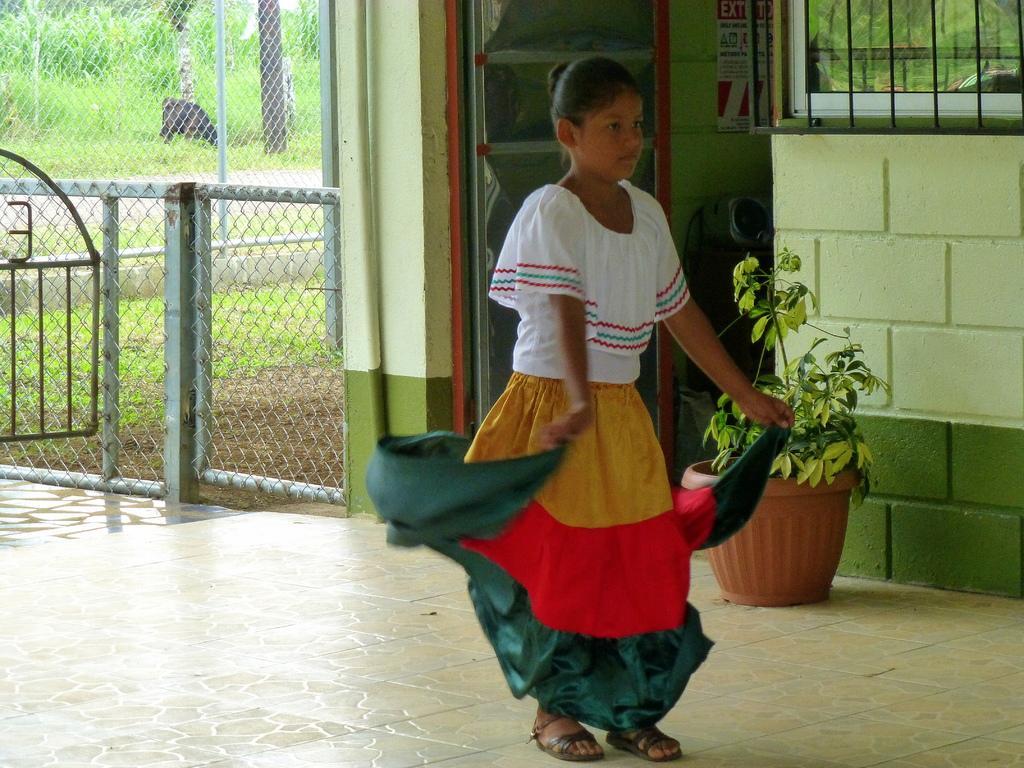In one or two sentences, can you explain what this image depicts? Here I can see a girl standing on the floor facing towards the right side. On the right side there is a room. Beside the wall there is a plant pot. At the back of this girl there is a door. Inside the room there are few objects placed on the floor and a poster is attached to the wall. Beside the poster there is a window. On the left side there is a net fencing. In the background, I can see the plants and trees on the ground. 